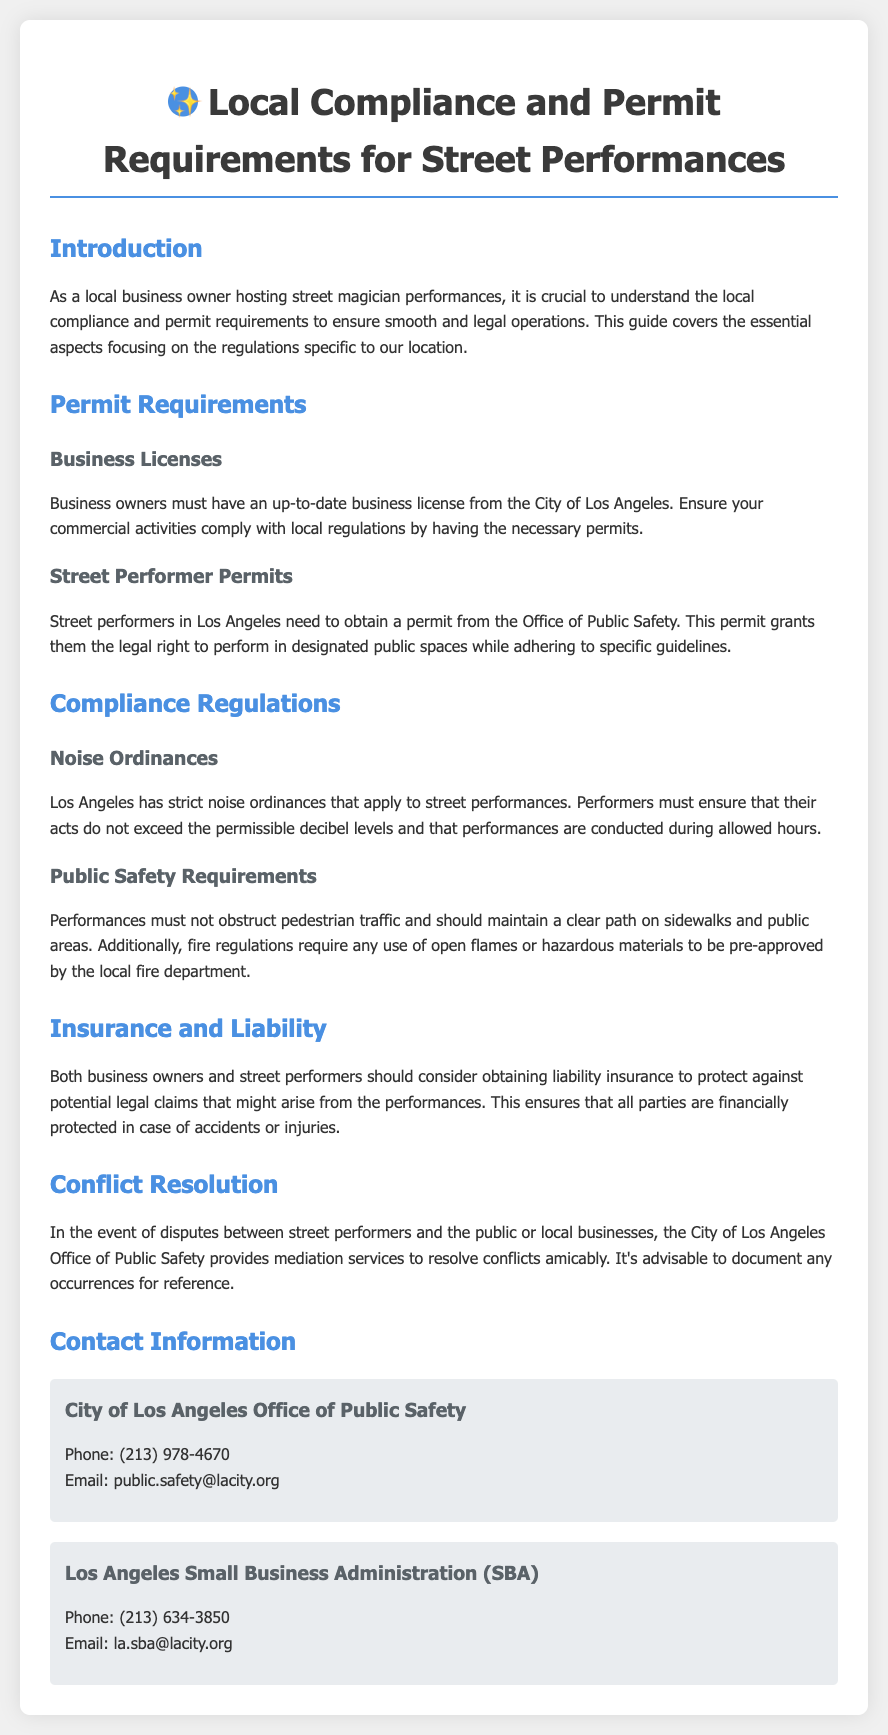What type of business license is required? The document states that an up-to-date business license from the City of Los Angeles is required.
Answer: Business license from the City of Los Angeles Who issues street performer permits? The street performer permits are issued by the Office of Public Safety.
Answer: Office of Public Safety What must performers adhere to regarding noise? Performers must ensure that their acts do not exceed permissible decibel levels and must perform during allowed hours.
Answer: Permissible decibel levels and allowed hours What is advised for both business owners and performers? The document advises obtaining liability insurance to protect against potential legal claims.
Answer: Liability insurance Which department pre-approves the use of open flames? The local fire department must pre-approve any use of open flames or hazardous materials.
Answer: Local fire department What mediation service does the City of Los Angeles provide? The City of Los Angeles Office of Public Safety provides mediation services to resolve conflicts.
Answer: Mediation services What is the phone number for the Office of Public Safety? The phone number for the Office of Public Safety is provided in the contact information section.
Answer: (213) 978-4670 What is required to avoid obstructing pedestrian traffic? Performances must not obstruct pedestrian traffic and maintain a clear path on sidewalks and public areas.
Answer: Clear path on sidewalks and public areas 